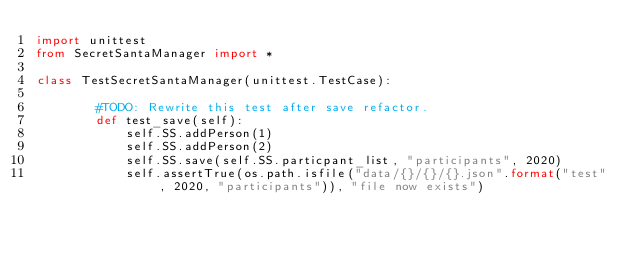Convert code to text. <code><loc_0><loc_0><loc_500><loc_500><_Python_>import unittest
from SecretSantaManager import *

class TestSecretSantaManager(unittest.TestCase):
        
        #TODO: Rewrite this test after save refactor.
        def test_save(self):
            self.SS.addPerson(1)
            self.SS.addPerson(2)
            self.SS.save(self.SS.particpant_list, "participants", 2020)
            self.assertTrue(os.path.isfile("data/{}/{}/{}.json".format("test", 2020, "participants")), "file now exists")</code> 